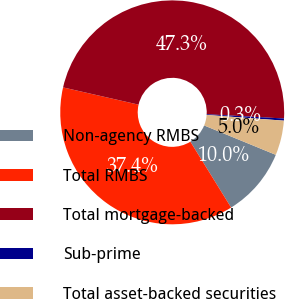Convert chart. <chart><loc_0><loc_0><loc_500><loc_500><pie_chart><fcel>Non-agency RMBS<fcel>Total RMBS<fcel>Total mortgage-backed<fcel>Sub-prime<fcel>Total asset-backed securities<nl><fcel>9.99%<fcel>37.39%<fcel>47.3%<fcel>0.31%<fcel>5.01%<nl></chart> 